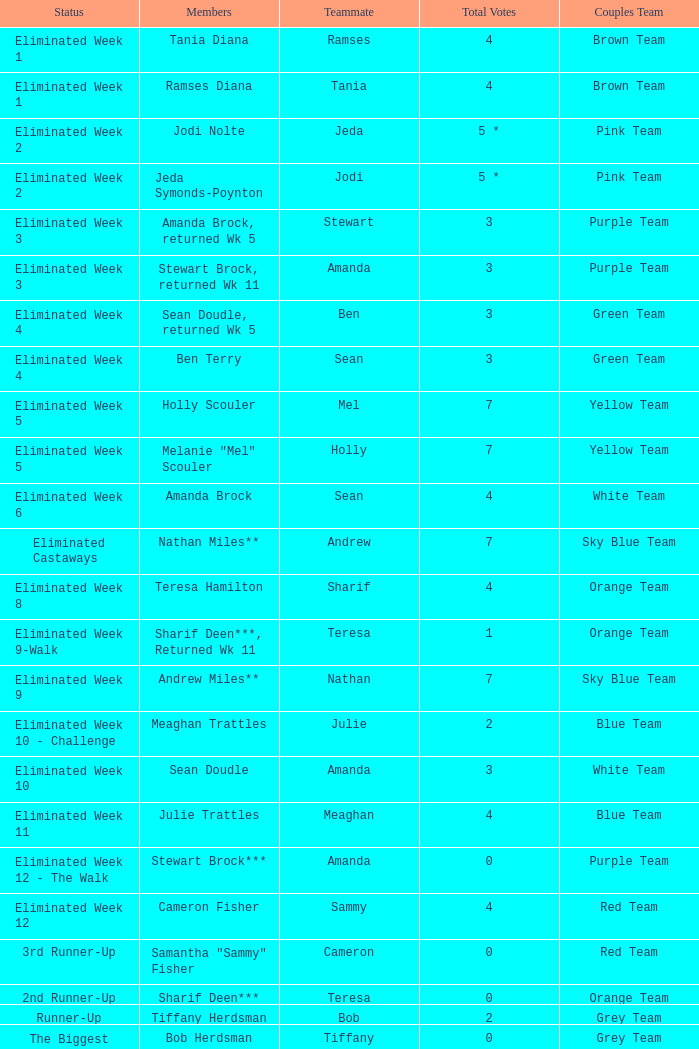What were Holly Scouler's total votes? 7.0. 